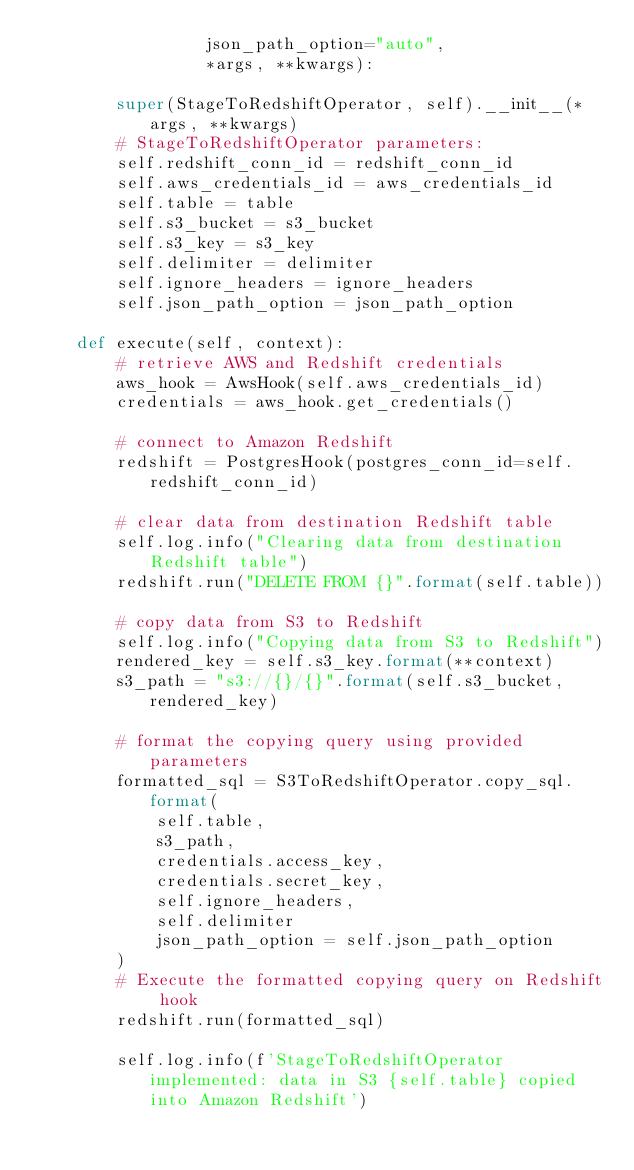Convert code to text. <code><loc_0><loc_0><loc_500><loc_500><_Python_>                 json_path_option="auto",
                 *args, **kwargs):

        super(StageToRedshiftOperator, self).__init__(*args, **kwargs)
        # StageToRedshiftOperator parameters:
        self.redshift_conn_id = redshift_conn_id
        self.aws_credentials_id = aws_credentials_id
        self.table = table
        self.s3_bucket = s3_bucket
        self.s3_key = s3_key
        self.delimiter = delimiter
        self.ignore_headers = ignore_headers
        self.json_path_option = json_path_option

    def execute(self, context):
        # retrieve AWS and Redshift credentials
        aws_hook = AwsHook(self.aws_credentials_id)
        credentials = aws_hook.get_credentials()
        
        # connect to Amazon Redshift
        redshift = PostgresHook(postgres_conn_id=self.redshift_conn_id)
        
        # clear data from destination Redshift table
        self.log.info("Clearing data from destination Redshift table")
        redshift.run("DELETE FROM {}".format(self.table))
        
        # copy data from S3 to Redshift
        self.log.info("Copying data from S3 to Redshift")
        rendered_key = self.s3_key.format(**context)
        s3_path = "s3://{}/{}".format(self.s3_bucket, rendered_key)
        
        # format the copying query using provided parameters
        formatted_sql = S3ToRedshiftOperator.copy_sql.format(
            self.table,
            s3_path,
            credentials.access_key,
            credentials.secret_key,
            self.ignore_headers,
            self.delimiter
            json_path_option = self.json_path_option
        )
        # Execute the formatted copying query on Redshift hook
        redshift.run(formatted_sql)
        
        self.log.info(f'StageToRedshiftOperator implemented: data in S3 {self.table} copied into Amazon Redshift')
</code> 